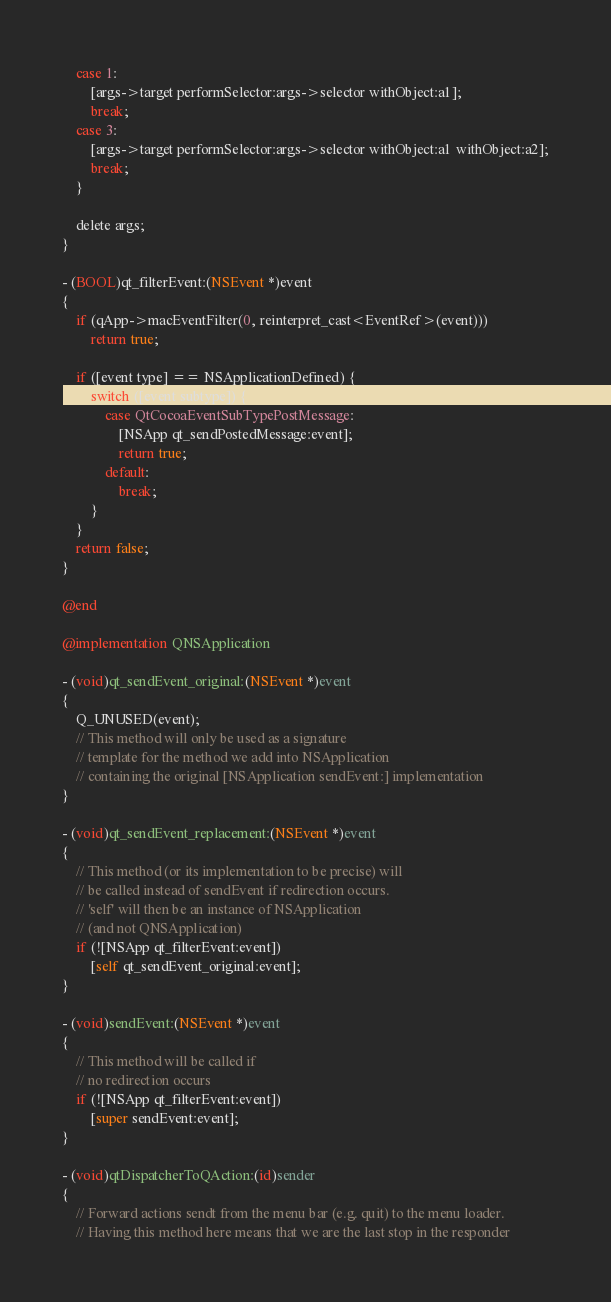<code> <loc_0><loc_0><loc_500><loc_500><_ObjectiveC_>    case 1:
        [args->target performSelector:args->selector withObject:a1];
        break;
    case 3:
        [args->target performSelector:args->selector withObject:a1 withObject:a2];
        break;
    }

    delete args;
}

- (BOOL)qt_filterEvent:(NSEvent *)event
{
    if (qApp->macEventFilter(0, reinterpret_cast<EventRef>(event)))
        return true;

    if ([event type] == NSApplicationDefined) {
        switch ([event subtype]) {
            case QtCocoaEventSubTypePostMessage:
                [NSApp qt_sendPostedMessage:event];
                return true;
            default:
                break;
        }
    }
    return false;
}

@end

@implementation QNSApplication

- (void)qt_sendEvent_original:(NSEvent *)event
{
    Q_UNUSED(event);
    // This method will only be used as a signature
    // template for the method we add into NSApplication
    // containing the original [NSApplication sendEvent:] implementation
}

- (void)qt_sendEvent_replacement:(NSEvent *)event
{
    // This method (or its implementation to be precise) will
    // be called instead of sendEvent if redirection occurs.
    // 'self' will then be an instance of NSApplication
    // (and not QNSApplication)
    if (![NSApp qt_filterEvent:event])
        [self qt_sendEvent_original:event];
}

- (void)sendEvent:(NSEvent *)event
{
    // This method will be called if
    // no redirection occurs
    if (![NSApp qt_filterEvent:event])
        [super sendEvent:event];
}

- (void)qtDispatcherToQAction:(id)sender
{
    // Forward actions sendt from the menu bar (e.g. quit) to the menu loader.
    // Having this method here means that we are the last stop in the responder</code> 